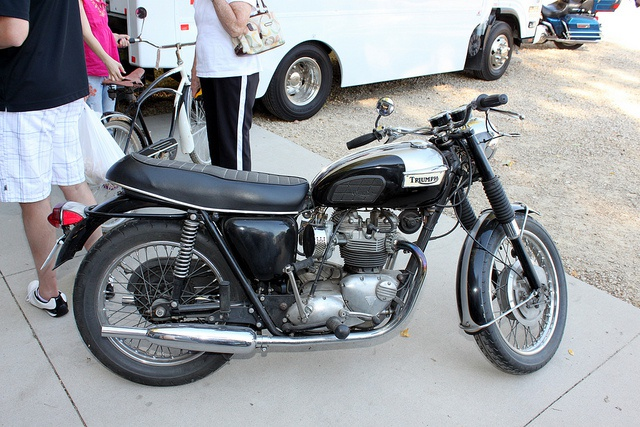Describe the objects in this image and their specific colors. I can see motorcycle in black, gray, darkgray, and lightgray tones, people in black, lavender, darkgray, and gray tones, truck in black, white, gray, and darkgray tones, people in black, lavender, darkgray, and pink tones, and bicycle in black, gray, darkgray, and lightgray tones in this image. 